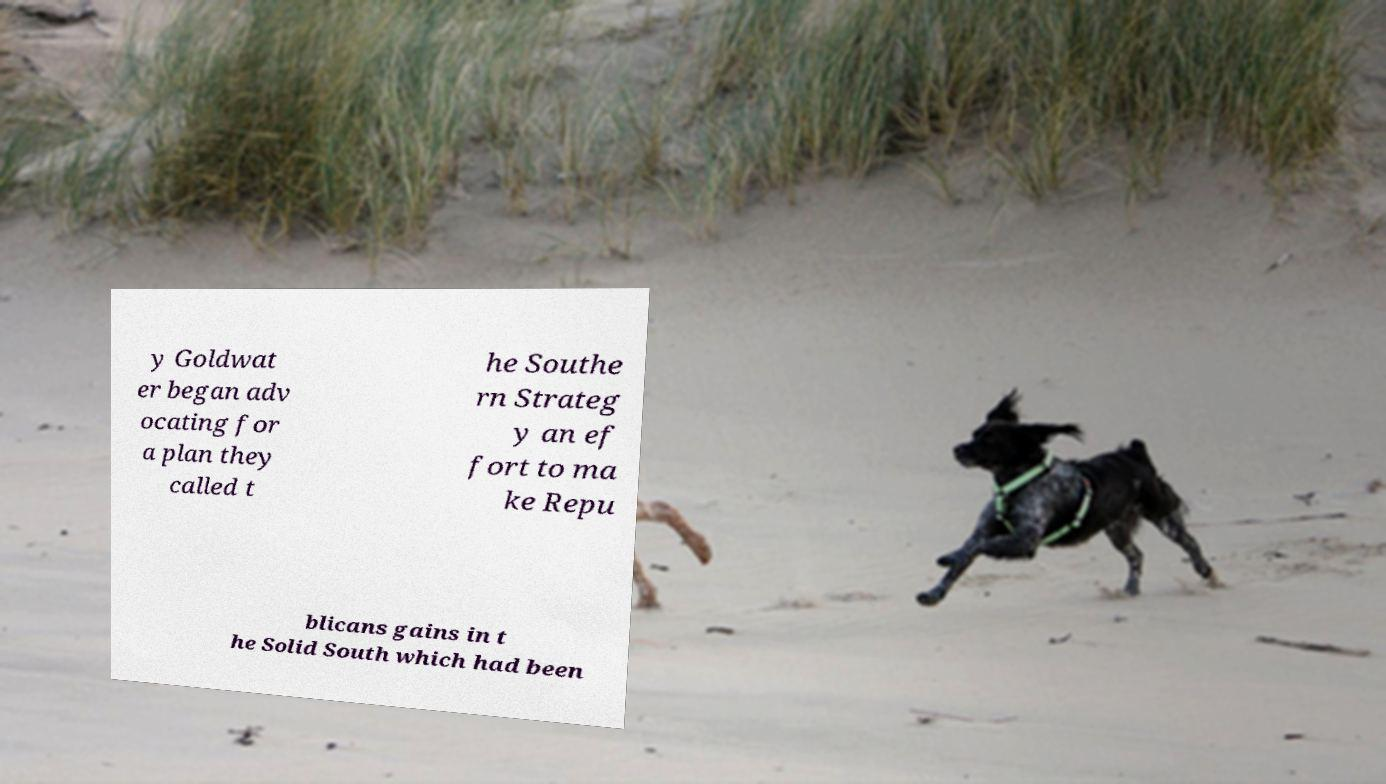For documentation purposes, I need the text within this image transcribed. Could you provide that? y Goldwat er began adv ocating for a plan they called t he Southe rn Strateg y an ef fort to ma ke Repu blicans gains in t he Solid South which had been 